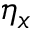<formula> <loc_0><loc_0><loc_500><loc_500>\eta _ { x }</formula> 